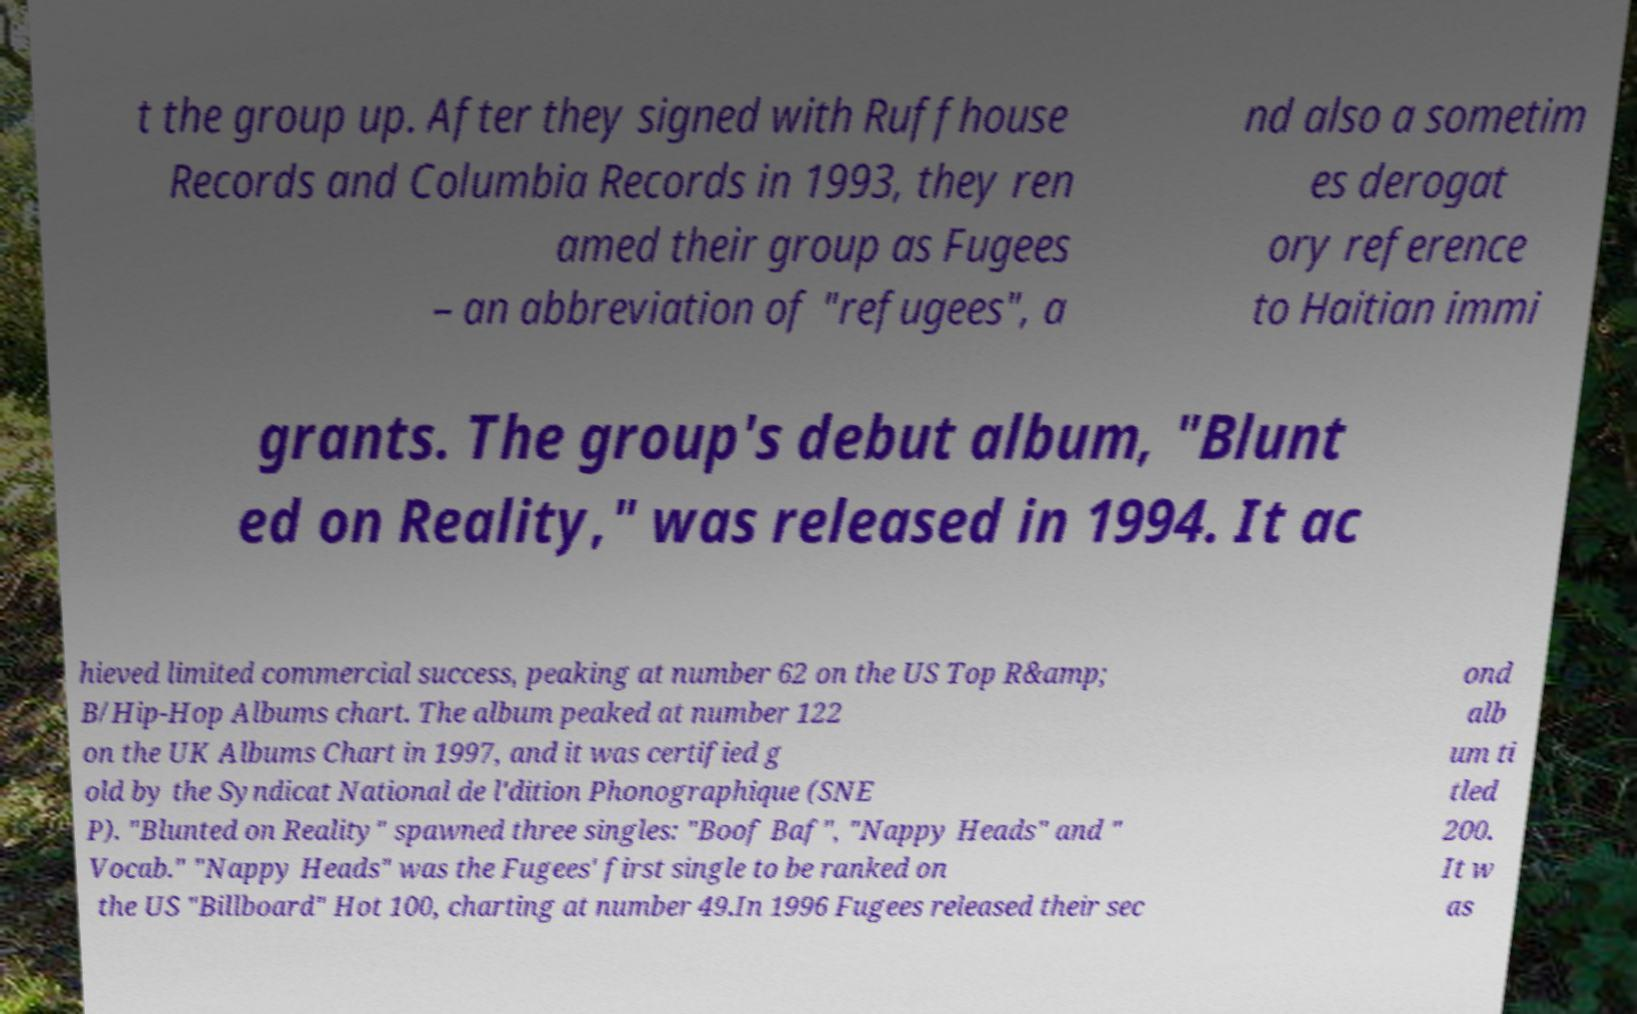I need the written content from this picture converted into text. Can you do that? t the group up. After they signed with Ruffhouse Records and Columbia Records in 1993, they ren amed their group as Fugees – an abbreviation of "refugees", a nd also a sometim es derogat ory reference to Haitian immi grants. The group's debut album, "Blunt ed on Reality," was released in 1994. It ac hieved limited commercial success, peaking at number 62 on the US Top R&amp; B/Hip-Hop Albums chart. The album peaked at number 122 on the UK Albums Chart in 1997, and it was certified g old by the Syndicat National de l'dition Phonographique (SNE P). "Blunted on Reality" spawned three singles: "Boof Baf", "Nappy Heads" and " Vocab." "Nappy Heads" was the Fugees' first single to be ranked on the US "Billboard" Hot 100, charting at number 49.In 1996 Fugees released their sec ond alb um ti tled 200. It w as 